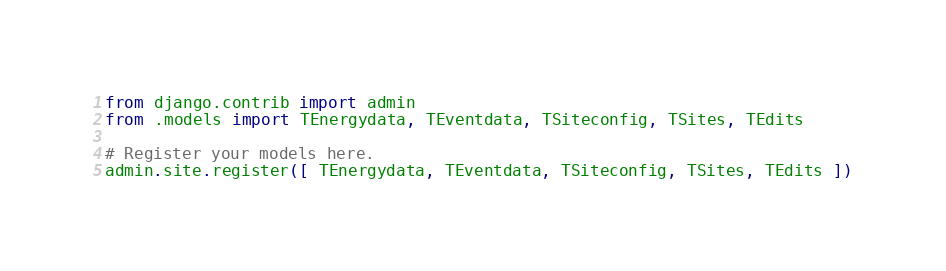<code> <loc_0><loc_0><loc_500><loc_500><_Python_>from django.contrib import admin
from .models import TEnergydata, TEventdata, TSiteconfig, TSites, TEdits

# Register your models here.
admin.site.register([ TEnergydata, TEventdata, TSiteconfig, TSites, TEdits ])</code> 